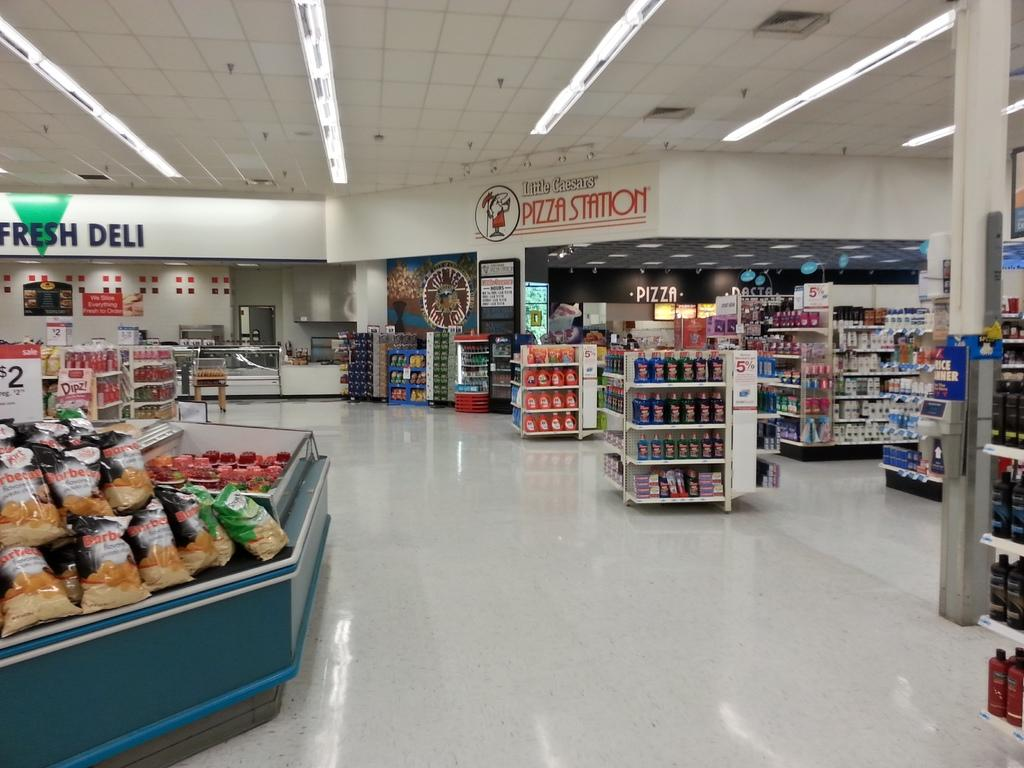<image>
Describe the image concisely. A little Caesar pizza store inside a supermarket 